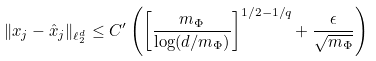Convert formula to latex. <formula><loc_0><loc_0><loc_500><loc_500>\| x _ { j } - \hat { x } _ { j } \| _ { \ell _ { 2 } ^ { d } } \leq C ^ { \prime } \left ( \left [ \frac { m _ { \Phi } } { \log ( d / m _ { \Phi } ) } \right ] ^ { 1 / 2 - 1 / q } + \frac { \epsilon } { \sqrt { m _ { \Phi } } } \right )</formula> 